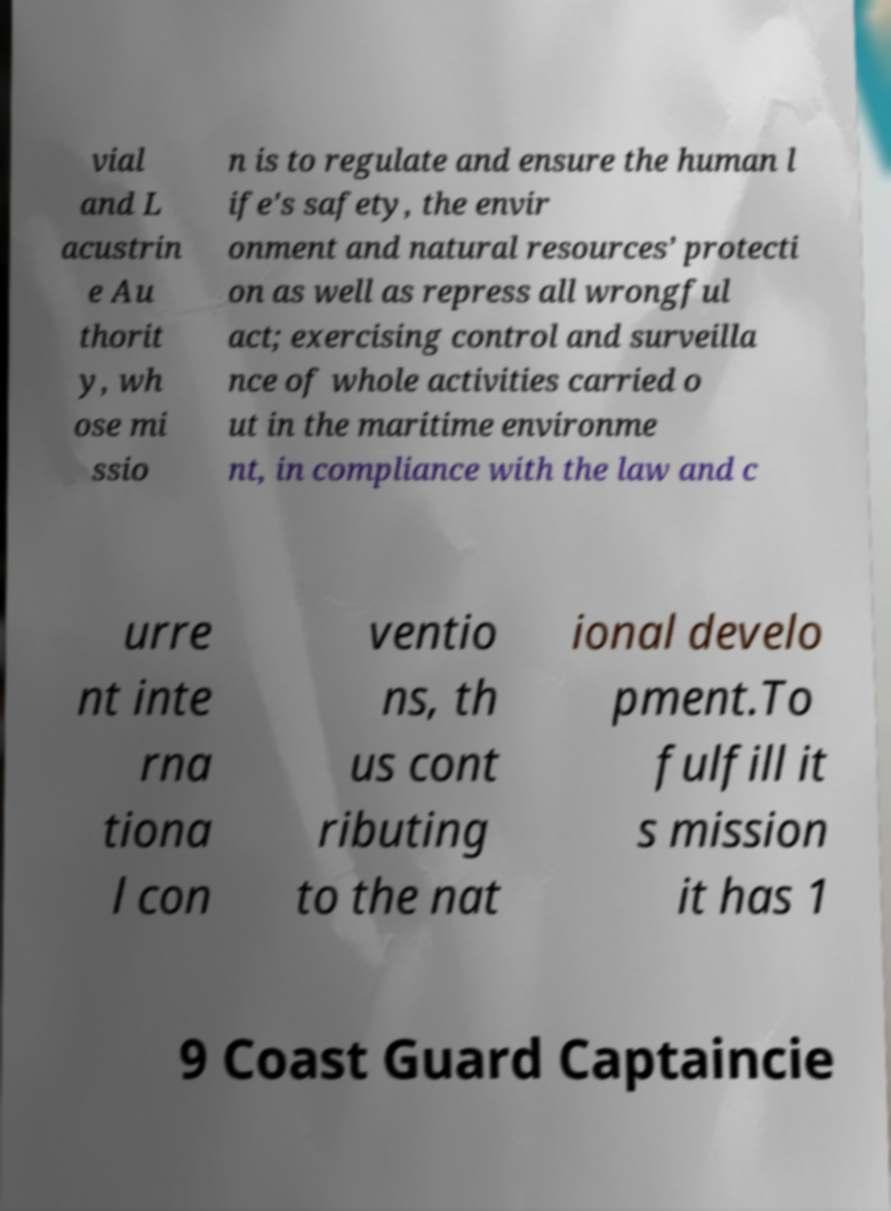What messages or text are displayed in this image? I need them in a readable, typed format. vial and L acustrin e Au thorit y, wh ose mi ssio n is to regulate and ensure the human l ife's safety, the envir onment and natural resources’ protecti on as well as repress all wrongful act; exercising control and surveilla nce of whole activities carried o ut in the maritime environme nt, in compliance with the law and c urre nt inte rna tiona l con ventio ns, th us cont ributing to the nat ional develo pment.To fulfill it s mission it has 1 9 Coast Guard Captaincie 